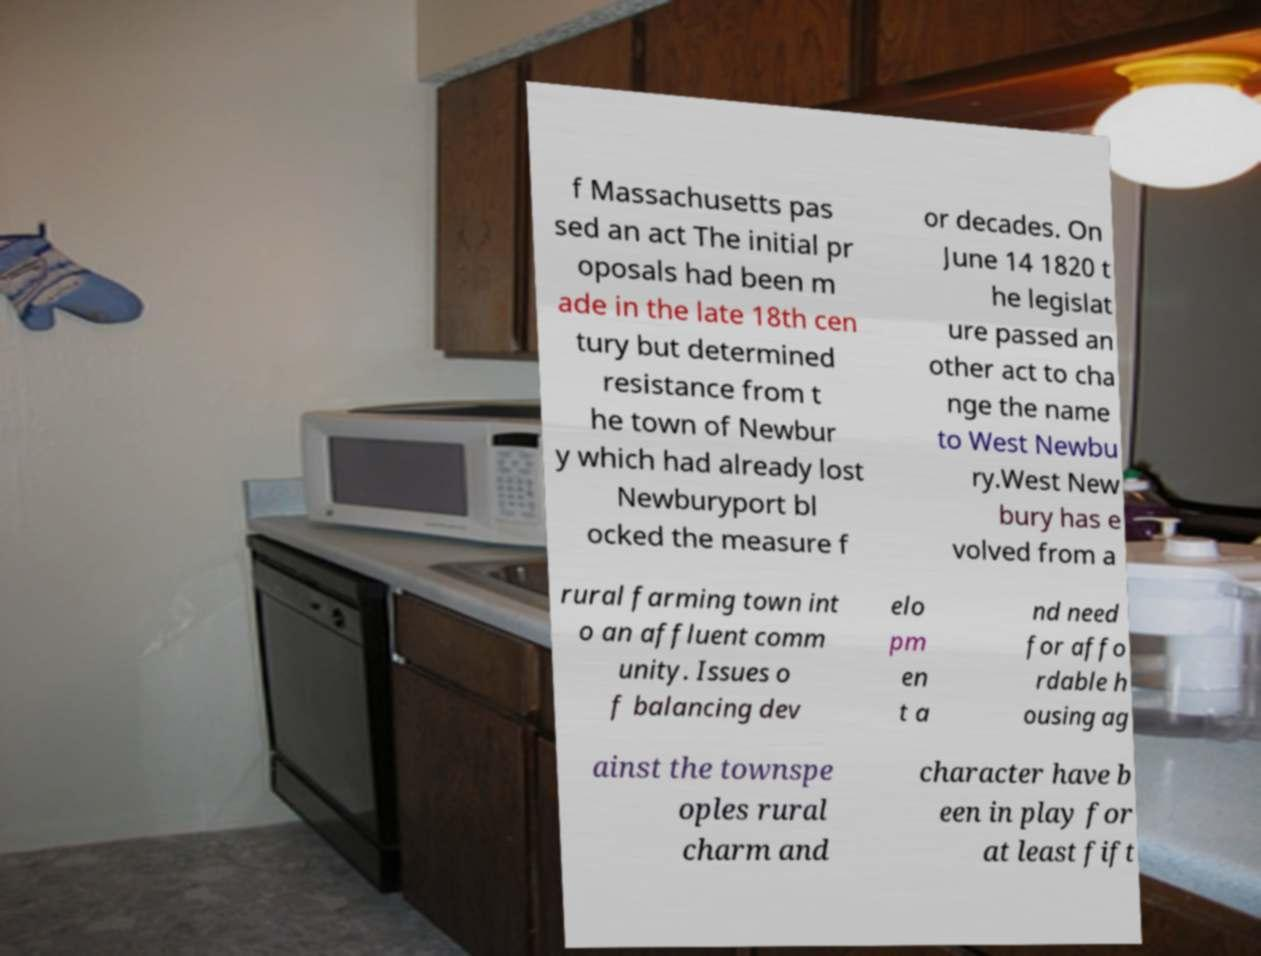Can you read and provide the text displayed in the image?This photo seems to have some interesting text. Can you extract and type it out for me? f Massachusetts pas sed an act The initial pr oposals had been m ade in the late 18th cen tury but determined resistance from t he town of Newbur y which had already lost Newburyport bl ocked the measure f or decades. On June 14 1820 t he legislat ure passed an other act to cha nge the name to West Newbu ry.West New bury has e volved from a rural farming town int o an affluent comm unity. Issues o f balancing dev elo pm en t a nd need for affo rdable h ousing ag ainst the townspe oples rural charm and character have b een in play for at least fift 